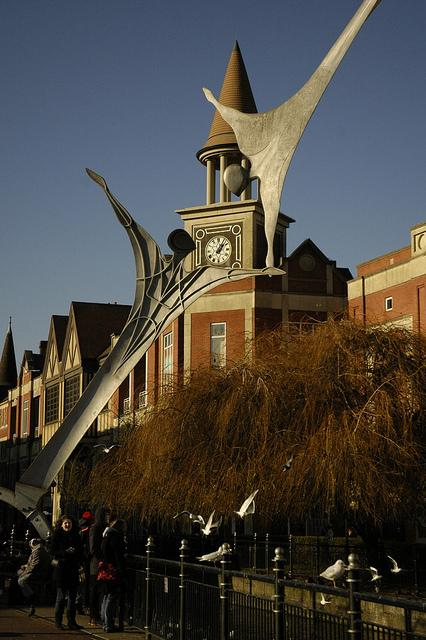The human-shaped decorations are made of what material?

Choices:
A) metal
B) wood
C) cement
D) plastic metal 